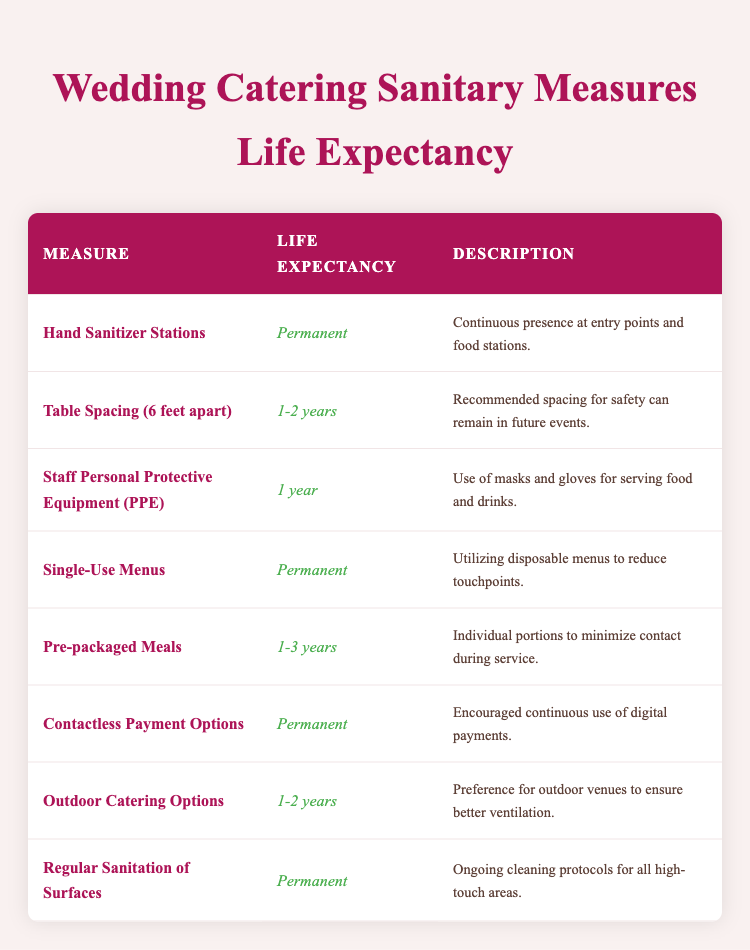What is the life expectancy of Hand Sanitizer Stations? The table indicates that the life expectancy of Hand Sanitizer Stations is listed as "Permanent." Thus, this measure is intended to be continually in place during events.
Answer: Permanent How long is the life expectancy of Staff Personal Protective Equipment (PPE)? According to the table, the life expectancy of Staff Personal Protective Equipment (PPE) is noted as "1 year." This suggests the use of masks and gloves for serving food will last for one year.
Answer: 1 year Which sanitary measure has a life expectancy of 1-3 years? The table reveals that Pre-packaged Meals have a life expectancy of "1-3 years." This means individual meal portions are likely to be used for this duration to minimize contact.
Answer: Pre-packaged Meals Are Contactless Payment Options expected to be used permanently? The data indicates that Contactless Payment Options are classified as "Permanent," suggesting that digital payments will continue to be promoted indefinitely for convenience and safety.
Answer: Yes What is the average life expectancy of measures that last for 1-2 years? The measures with a life expectancy of 1-2 years include Table Spacing and Outdoor Catering Options. Adding their life expectancies would yield (1.5 years + 1.5 years) / 2 = 1.5 years on average.
Answer: 1.5 years What is the total number of sanitary measures expected to last for a permanent duration? The table shows that there are four measures with a life expectancy of "Permanent" (Hand Sanitizer Stations, Single-Use Menus, Contactless Payment Options, and Regular Sanitation of Surfaces). Therefore, the total is 4.
Answer: 4 If I wanted to ensure maximum safety for an event, which measures should I consider? To ensure maximum safety, I should consider the Permanent measures (Hand Sanitizer Stations, Single-Use Menus, Contactless Payment Options, and Regular Sanitation of Surfaces) along with the Pre-packaged Meals and Table Spacing options that last for 1-2 years. This combination would ensure ongoing safety protocols.
Answer: Permanent measures + Pre-packaged Meals + Table Spacing Do any sanitary measures last longer than 3 years? By examining the data, none of the sanitary measures are indicated to have a life expectancy longer than 3 years. The longest listed is Pre-packaged Meals at "1-3 years."
Answer: No 